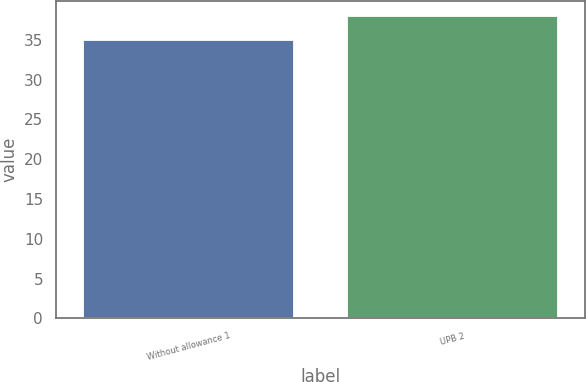Convert chart. <chart><loc_0><loc_0><loc_500><loc_500><bar_chart><fcel>Without allowance 1<fcel>UPB 2<nl><fcel>35<fcel>38<nl></chart> 